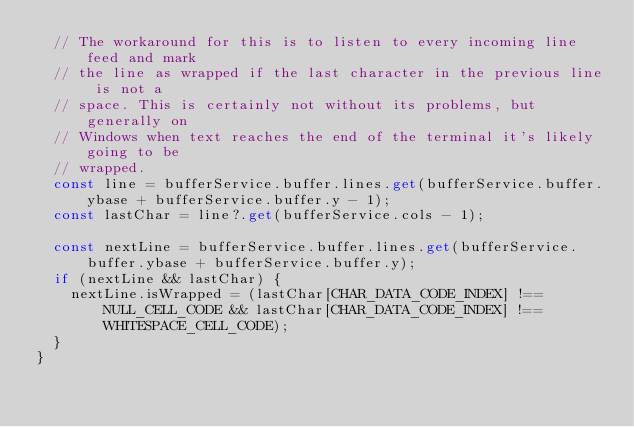Convert code to text. <code><loc_0><loc_0><loc_500><loc_500><_TypeScript_>  // The workaround for this is to listen to every incoming line feed and mark
  // the line as wrapped if the last character in the previous line is not a
  // space. This is certainly not without its problems, but generally on
  // Windows when text reaches the end of the terminal it's likely going to be
  // wrapped.
  const line = bufferService.buffer.lines.get(bufferService.buffer.ybase + bufferService.buffer.y - 1);
  const lastChar = line?.get(bufferService.cols - 1);

  const nextLine = bufferService.buffer.lines.get(bufferService.buffer.ybase + bufferService.buffer.y);
  if (nextLine && lastChar) {
    nextLine.isWrapped = (lastChar[CHAR_DATA_CODE_INDEX] !== NULL_CELL_CODE && lastChar[CHAR_DATA_CODE_INDEX] !== WHITESPACE_CELL_CODE);
  }
}
</code> 